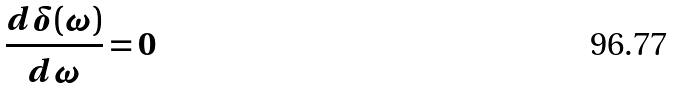<formula> <loc_0><loc_0><loc_500><loc_500>\frac { d \delta ( \omega ) } { d \omega } = 0</formula> 